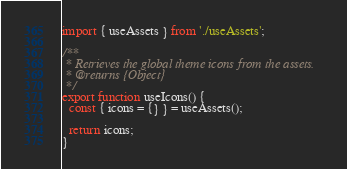Convert code to text. <code><loc_0><loc_0><loc_500><loc_500><_JavaScript_>import { useAssets } from './useAssets';

/**
 * Retrieves the global theme icons from the assets.
 * @returns {Object}
 */
export function useIcons() {
  const { icons = {} } = useAssets();

  return icons;
}
</code> 